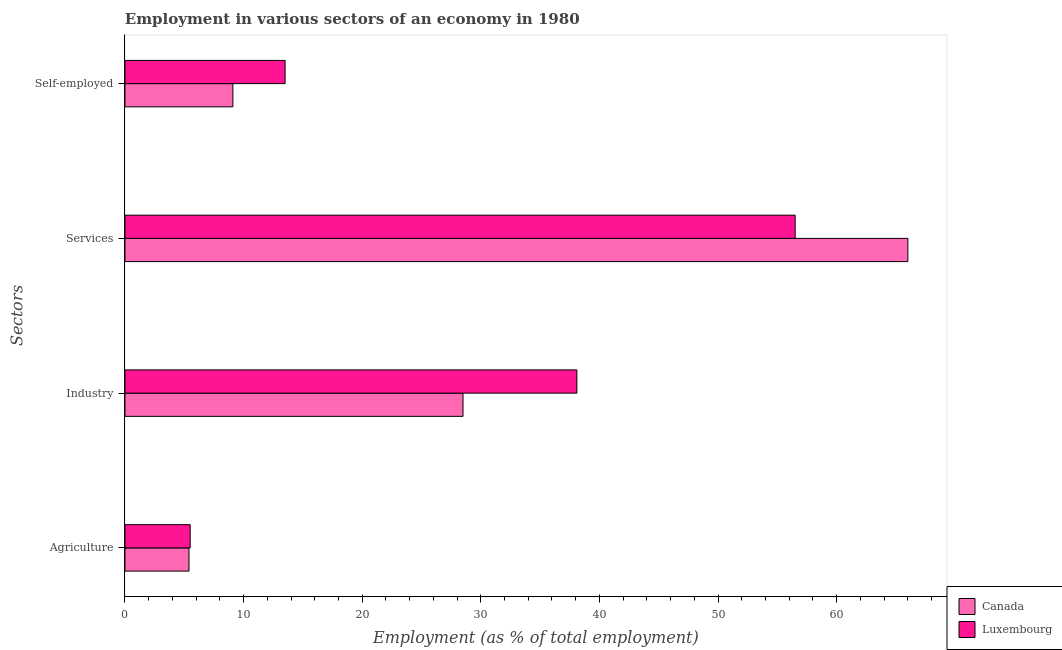Are the number of bars per tick equal to the number of legend labels?
Offer a very short reply. Yes. How many bars are there on the 3rd tick from the top?
Offer a very short reply. 2. How many bars are there on the 1st tick from the bottom?
Offer a terse response. 2. What is the label of the 2nd group of bars from the top?
Provide a succinct answer. Services. What is the percentage of workers in services in Luxembourg?
Offer a very short reply. 56.5. Across all countries, what is the maximum percentage of workers in industry?
Give a very brief answer. 38.1. Across all countries, what is the minimum percentage of workers in agriculture?
Make the answer very short. 5.4. In which country was the percentage of workers in agriculture maximum?
Ensure brevity in your answer.  Luxembourg. What is the total percentage of workers in services in the graph?
Your answer should be very brief. 122.5. What is the difference between the percentage of workers in industry in Luxembourg and that in Canada?
Ensure brevity in your answer.  9.6. What is the difference between the percentage of self employed workers in Luxembourg and the percentage of workers in services in Canada?
Offer a terse response. -52.5. What is the average percentage of workers in industry per country?
Offer a terse response. 33.3. What is the difference between the percentage of self employed workers and percentage of workers in services in Canada?
Provide a short and direct response. -56.9. In how many countries, is the percentage of self employed workers greater than 18 %?
Ensure brevity in your answer.  0. What is the ratio of the percentage of workers in services in Luxembourg to that in Canada?
Offer a terse response. 0.86. Is the percentage of workers in agriculture in Canada less than that in Luxembourg?
Your answer should be compact. Yes. What is the difference between the highest and the second highest percentage of self employed workers?
Provide a short and direct response. 4.4. What is the difference between the highest and the lowest percentage of workers in services?
Give a very brief answer. 9.5. What does the 1st bar from the top in Services represents?
Keep it short and to the point. Luxembourg. What does the 2nd bar from the bottom in Services represents?
Make the answer very short. Luxembourg. Is it the case that in every country, the sum of the percentage of workers in agriculture and percentage of workers in industry is greater than the percentage of workers in services?
Make the answer very short. No. How many bars are there?
Your response must be concise. 8. Are all the bars in the graph horizontal?
Your answer should be very brief. Yes. How many countries are there in the graph?
Provide a short and direct response. 2. Does the graph contain any zero values?
Offer a very short reply. No. How many legend labels are there?
Give a very brief answer. 2. How are the legend labels stacked?
Make the answer very short. Vertical. What is the title of the graph?
Offer a terse response. Employment in various sectors of an economy in 1980. What is the label or title of the X-axis?
Offer a terse response. Employment (as % of total employment). What is the label or title of the Y-axis?
Keep it short and to the point. Sectors. What is the Employment (as % of total employment) of Canada in Agriculture?
Make the answer very short. 5.4. What is the Employment (as % of total employment) of Canada in Industry?
Offer a terse response. 28.5. What is the Employment (as % of total employment) in Luxembourg in Industry?
Your answer should be very brief. 38.1. What is the Employment (as % of total employment) of Canada in Services?
Provide a succinct answer. 66. What is the Employment (as % of total employment) of Luxembourg in Services?
Offer a very short reply. 56.5. What is the Employment (as % of total employment) in Canada in Self-employed?
Offer a terse response. 9.1. Across all Sectors, what is the maximum Employment (as % of total employment) of Luxembourg?
Provide a succinct answer. 56.5. Across all Sectors, what is the minimum Employment (as % of total employment) of Canada?
Offer a very short reply. 5.4. Across all Sectors, what is the minimum Employment (as % of total employment) in Luxembourg?
Keep it short and to the point. 5.5. What is the total Employment (as % of total employment) in Canada in the graph?
Provide a short and direct response. 109. What is the total Employment (as % of total employment) in Luxembourg in the graph?
Your answer should be very brief. 113.6. What is the difference between the Employment (as % of total employment) of Canada in Agriculture and that in Industry?
Make the answer very short. -23.1. What is the difference between the Employment (as % of total employment) in Luxembourg in Agriculture and that in Industry?
Ensure brevity in your answer.  -32.6. What is the difference between the Employment (as % of total employment) of Canada in Agriculture and that in Services?
Provide a succinct answer. -60.6. What is the difference between the Employment (as % of total employment) of Luxembourg in Agriculture and that in Services?
Make the answer very short. -51. What is the difference between the Employment (as % of total employment) of Canada in Agriculture and that in Self-employed?
Your answer should be compact. -3.7. What is the difference between the Employment (as % of total employment) of Canada in Industry and that in Services?
Make the answer very short. -37.5. What is the difference between the Employment (as % of total employment) in Luxembourg in Industry and that in Services?
Provide a short and direct response. -18.4. What is the difference between the Employment (as % of total employment) of Canada in Industry and that in Self-employed?
Your answer should be very brief. 19.4. What is the difference between the Employment (as % of total employment) of Luxembourg in Industry and that in Self-employed?
Your answer should be very brief. 24.6. What is the difference between the Employment (as % of total employment) of Canada in Services and that in Self-employed?
Your response must be concise. 56.9. What is the difference between the Employment (as % of total employment) in Luxembourg in Services and that in Self-employed?
Keep it short and to the point. 43. What is the difference between the Employment (as % of total employment) in Canada in Agriculture and the Employment (as % of total employment) in Luxembourg in Industry?
Ensure brevity in your answer.  -32.7. What is the difference between the Employment (as % of total employment) in Canada in Agriculture and the Employment (as % of total employment) in Luxembourg in Services?
Keep it short and to the point. -51.1. What is the difference between the Employment (as % of total employment) of Canada in Industry and the Employment (as % of total employment) of Luxembourg in Services?
Keep it short and to the point. -28. What is the difference between the Employment (as % of total employment) in Canada in Services and the Employment (as % of total employment) in Luxembourg in Self-employed?
Ensure brevity in your answer.  52.5. What is the average Employment (as % of total employment) in Canada per Sectors?
Offer a terse response. 27.25. What is the average Employment (as % of total employment) in Luxembourg per Sectors?
Your answer should be very brief. 28.4. What is the difference between the Employment (as % of total employment) of Canada and Employment (as % of total employment) of Luxembourg in Agriculture?
Provide a succinct answer. -0.1. What is the difference between the Employment (as % of total employment) in Canada and Employment (as % of total employment) in Luxembourg in Self-employed?
Provide a short and direct response. -4.4. What is the ratio of the Employment (as % of total employment) of Canada in Agriculture to that in Industry?
Your answer should be compact. 0.19. What is the ratio of the Employment (as % of total employment) in Luxembourg in Agriculture to that in Industry?
Your answer should be very brief. 0.14. What is the ratio of the Employment (as % of total employment) of Canada in Agriculture to that in Services?
Your answer should be very brief. 0.08. What is the ratio of the Employment (as % of total employment) in Luxembourg in Agriculture to that in Services?
Give a very brief answer. 0.1. What is the ratio of the Employment (as % of total employment) of Canada in Agriculture to that in Self-employed?
Your response must be concise. 0.59. What is the ratio of the Employment (as % of total employment) in Luxembourg in Agriculture to that in Self-employed?
Give a very brief answer. 0.41. What is the ratio of the Employment (as % of total employment) in Canada in Industry to that in Services?
Offer a terse response. 0.43. What is the ratio of the Employment (as % of total employment) in Luxembourg in Industry to that in Services?
Ensure brevity in your answer.  0.67. What is the ratio of the Employment (as % of total employment) in Canada in Industry to that in Self-employed?
Ensure brevity in your answer.  3.13. What is the ratio of the Employment (as % of total employment) of Luxembourg in Industry to that in Self-employed?
Ensure brevity in your answer.  2.82. What is the ratio of the Employment (as % of total employment) in Canada in Services to that in Self-employed?
Make the answer very short. 7.25. What is the ratio of the Employment (as % of total employment) of Luxembourg in Services to that in Self-employed?
Make the answer very short. 4.19. What is the difference between the highest and the second highest Employment (as % of total employment) of Canada?
Your answer should be very brief. 37.5. What is the difference between the highest and the lowest Employment (as % of total employment) of Canada?
Your answer should be compact. 60.6. 